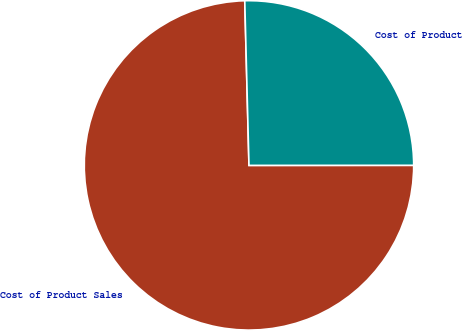Convert chart. <chart><loc_0><loc_0><loc_500><loc_500><pie_chart><fcel>Cost of Product Sales<fcel>Cost of Product<nl><fcel>74.6%<fcel>25.4%<nl></chart> 